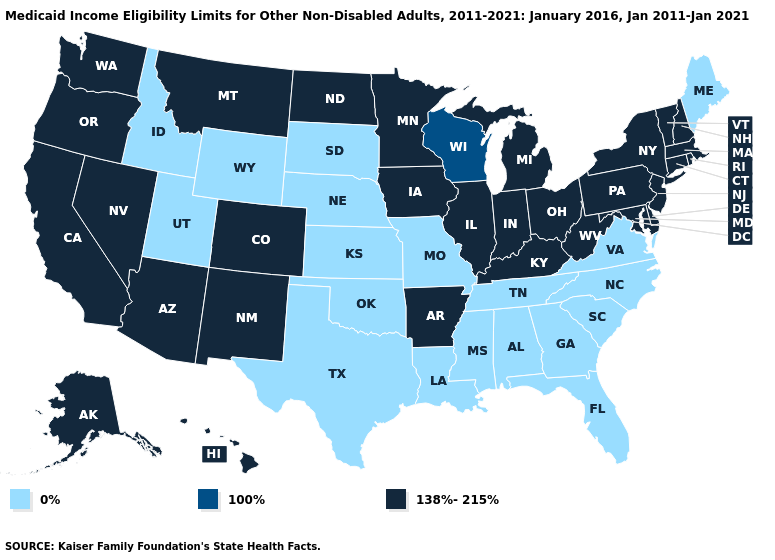What is the lowest value in the USA?
Quick response, please. 0%. Does Idaho have the lowest value in the USA?
Give a very brief answer. Yes. Name the states that have a value in the range 0%?
Write a very short answer. Alabama, Florida, Georgia, Idaho, Kansas, Louisiana, Maine, Mississippi, Missouri, Nebraska, North Carolina, Oklahoma, South Carolina, South Dakota, Tennessee, Texas, Utah, Virginia, Wyoming. Name the states that have a value in the range 138%-215%?
Be succinct. Alaska, Arizona, Arkansas, California, Colorado, Connecticut, Delaware, Hawaii, Illinois, Indiana, Iowa, Kentucky, Maryland, Massachusetts, Michigan, Minnesota, Montana, Nevada, New Hampshire, New Jersey, New Mexico, New York, North Dakota, Ohio, Oregon, Pennsylvania, Rhode Island, Vermont, Washington, West Virginia. Among the states that border Rhode Island , which have the highest value?
Answer briefly. Connecticut, Massachusetts. What is the highest value in the USA?
Quick response, please. 138%-215%. Which states have the highest value in the USA?
Write a very short answer. Alaska, Arizona, Arkansas, California, Colorado, Connecticut, Delaware, Hawaii, Illinois, Indiana, Iowa, Kentucky, Maryland, Massachusetts, Michigan, Minnesota, Montana, Nevada, New Hampshire, New Jersey, New Mexico, New York, North Dakota, Ohio, Oregon, Pennsylvania, Rhode Island, Vermont, Washington, West Virginia. Name the states that have a value in the range 0%?
Concise answer only. Alabama, Florida, Georgia, Idaho, Kansas, Louisiana, Maine, Mississippi, Missouri, Nebraska, North Carolina, Oklahoma, South Carolina, South Dakota, Tennessee, Texas, Utah, Virginia, Wyoming. What is the highest value in states that border Indiana?
Answer briefly. 138%-215%. What is the highest value in states that border New Hampshire?
Give a very brief answer. 138%-215%. Does Maryland have the highest value in the South?
Concise answer only. Yes. Name the states that have a value in the range 138%-215%?
Short answer required. Alaska, Arizona, Arkansas, California, Colorado, Connecticut, Delaware, Hawaii, Illinois, Indiana, Iowa, Kentucky, Maryland, Massachusetts, Michigan, Minnesota, Montana, Nevada, New Hampshire, New Jersey, New Mexico, New York, North Dakota, Ohio, Oregon, Pennsylvania, Rhode Island, Vermont, Washington, West Virginia. Name the states that have a value in the range 0%?
Give a very brief answer. Alabama, Florida, Georgia, Idaho, Kansas, Louisiana, Maine, Mississippi, Missouri, Nebraska, North Carolina, Oklahoma, South Carolina, South Dakota, Tennessee, Texas, Utah, Virginia, Wyoming. What is the value of Tennessee?
Answer briefly. 0%. 